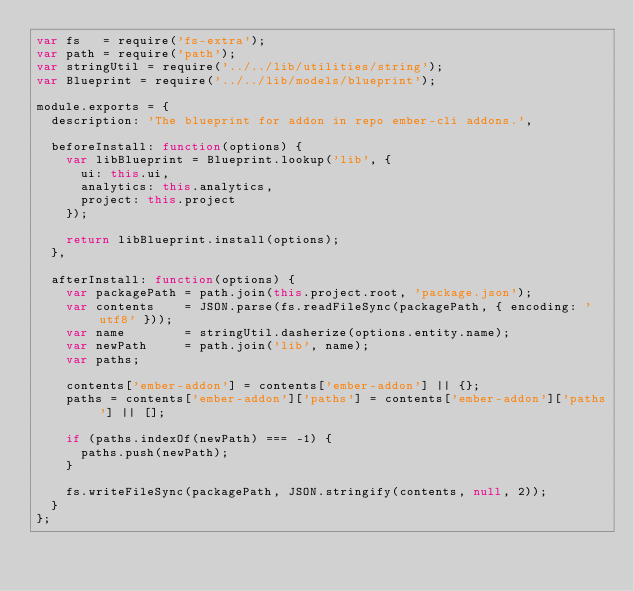<code> <loc_0><loc_0><loc_500><loc_500><_JavaScript_>var fs   = require('fs-extra');
var path = require('path');
var stringUtil = require('../../lib/utilities/string');
var Blueprint = require('../../lib/models/blueprint');

module.exports = {
  description: 'The blueprint for addon in repo ember-cli addons.',

  beforeInstall: function(options) {
    var libBlueprint = Blueprint.lookup('lib', {
      ui: this.ui,
      analytics: this.analytics,
      project: this.project
    });

    return libBlueprint.install(options);
  },

  afterInstall: function(options) {
    var packagePath = path.join(this.project.root, 'package.json');
    var contents    = JSON.parse(fs.readFileSync(packagePath, { encoding: 'utf8' }));
    var name        = stringUtil.dasherize(options.entity.name);
    var newPath     = path.join('lib', name);
    var paths;

    contents['ember-addon'] = contents['ember-addon'] || {};
    paths = contents['ember-addon']['paths'] = contents['ember-addon']['paths'] || [];

    if (paths.indexOf(newPath) === -1) {
      paths.push(newPath);
    }

    fs.writeFileSync(packagePath, JSON.stringify(contents, null, 2));
  }
};
</code> 